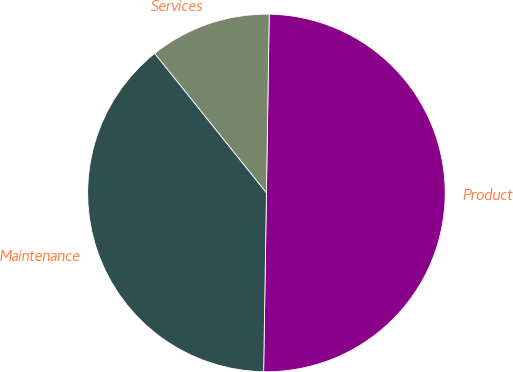<chart> <loc_0><loc_0><loc_500><loc_500><pie_chart><fcel>Product<fcel>Services<fcel>Maintenance<nl><fcel>50.0%<fcel>11.0%<fcel>39.0%<nl></chart> 